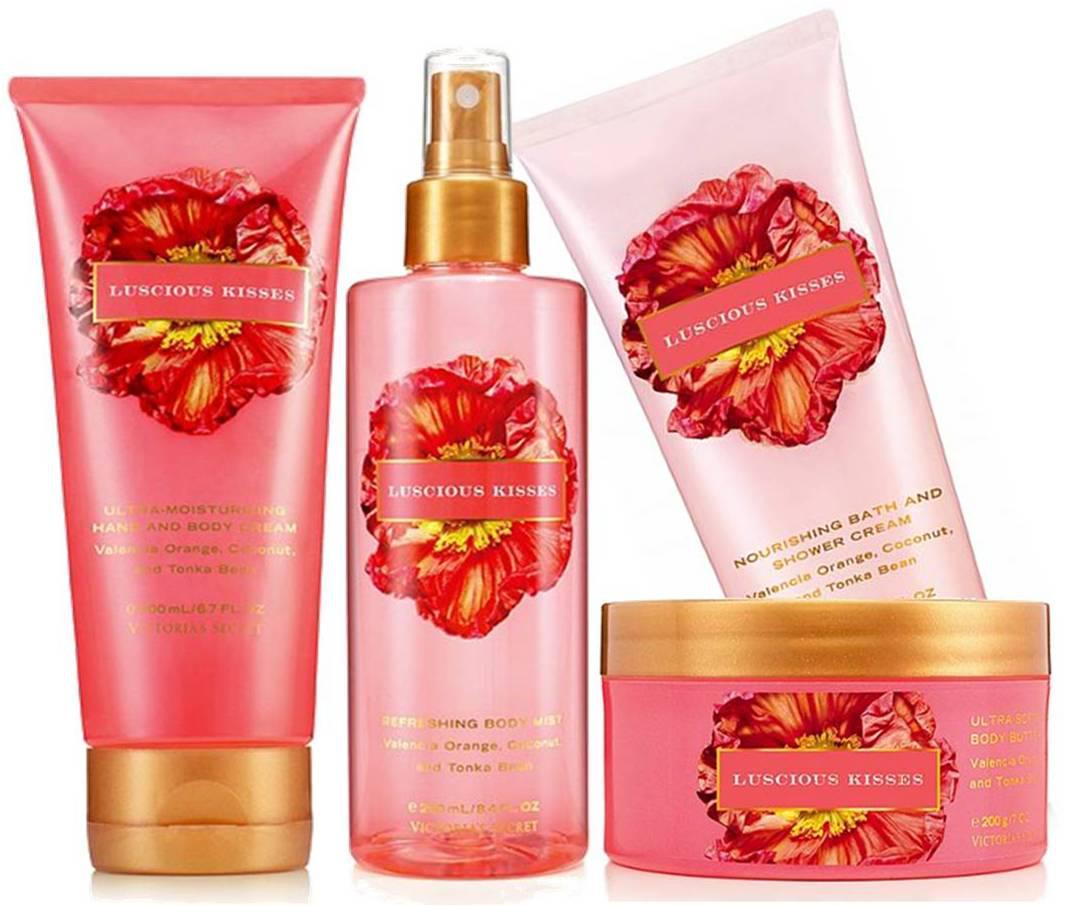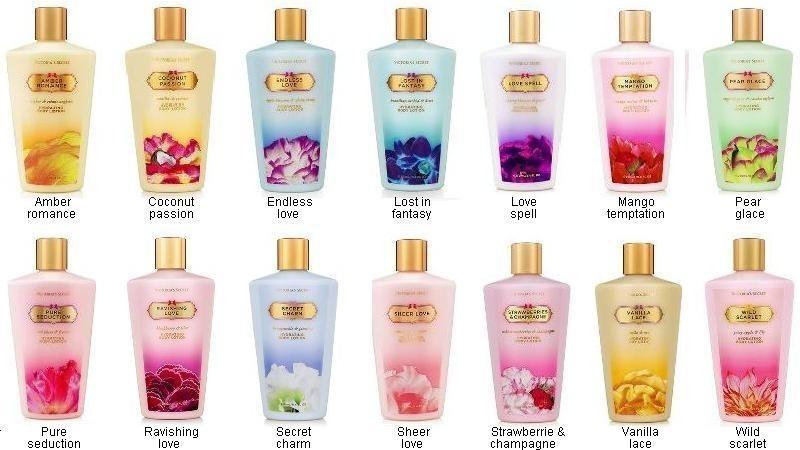The first image is the image on the left, the second image is the image on the right. For the images shown, is this caption "The right image includes only products with shiny gold caps and includes at least one tube-type product designed to stand on its cap." true? Answer yes or no. No. 